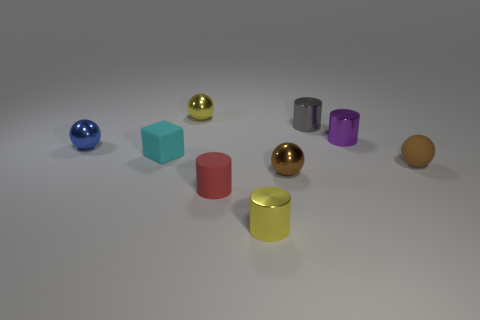Add 1 tiny blue spheres. How many objects exist? 10 Subtract all blocks. How many objects are left? 8 Add 3 yellow shiny objects. How many yellow shiny objects are left? 5 Add 1 small cyan things. How many small cyan things exist? 2 Subtract 0 red cubes. How many objects are left? 9 Subtract all large red rubber cubes. Subtract all brown objects. How many objects are left? 7 